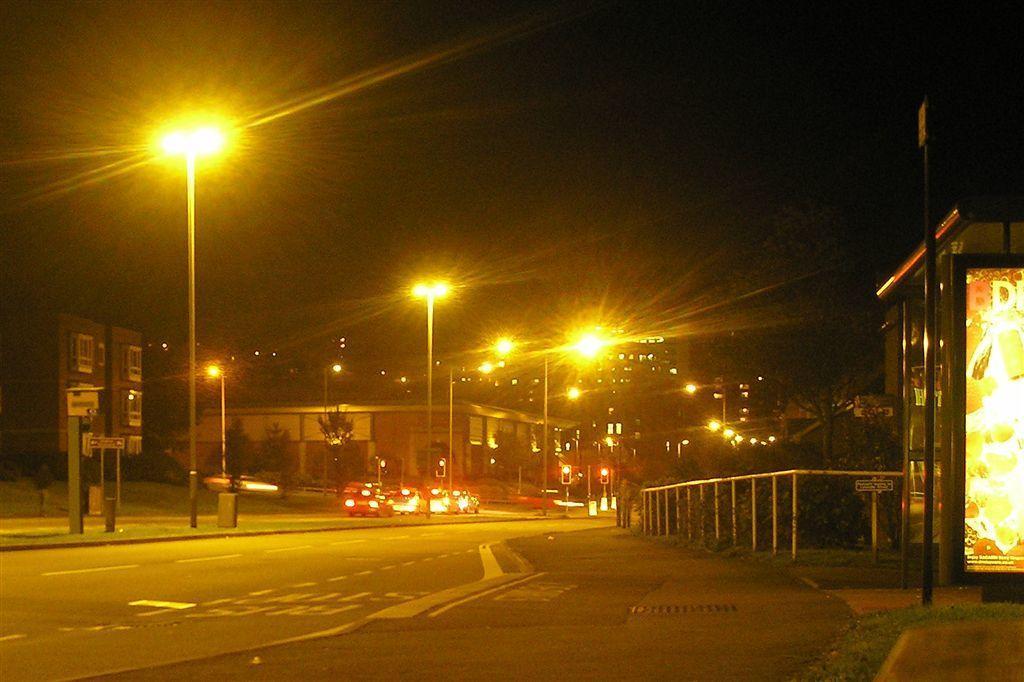Could you give a brief overview of what you see in this image? In this image we can see motor vehicles on the road, street poles, street lights, fence, trees and sky. 